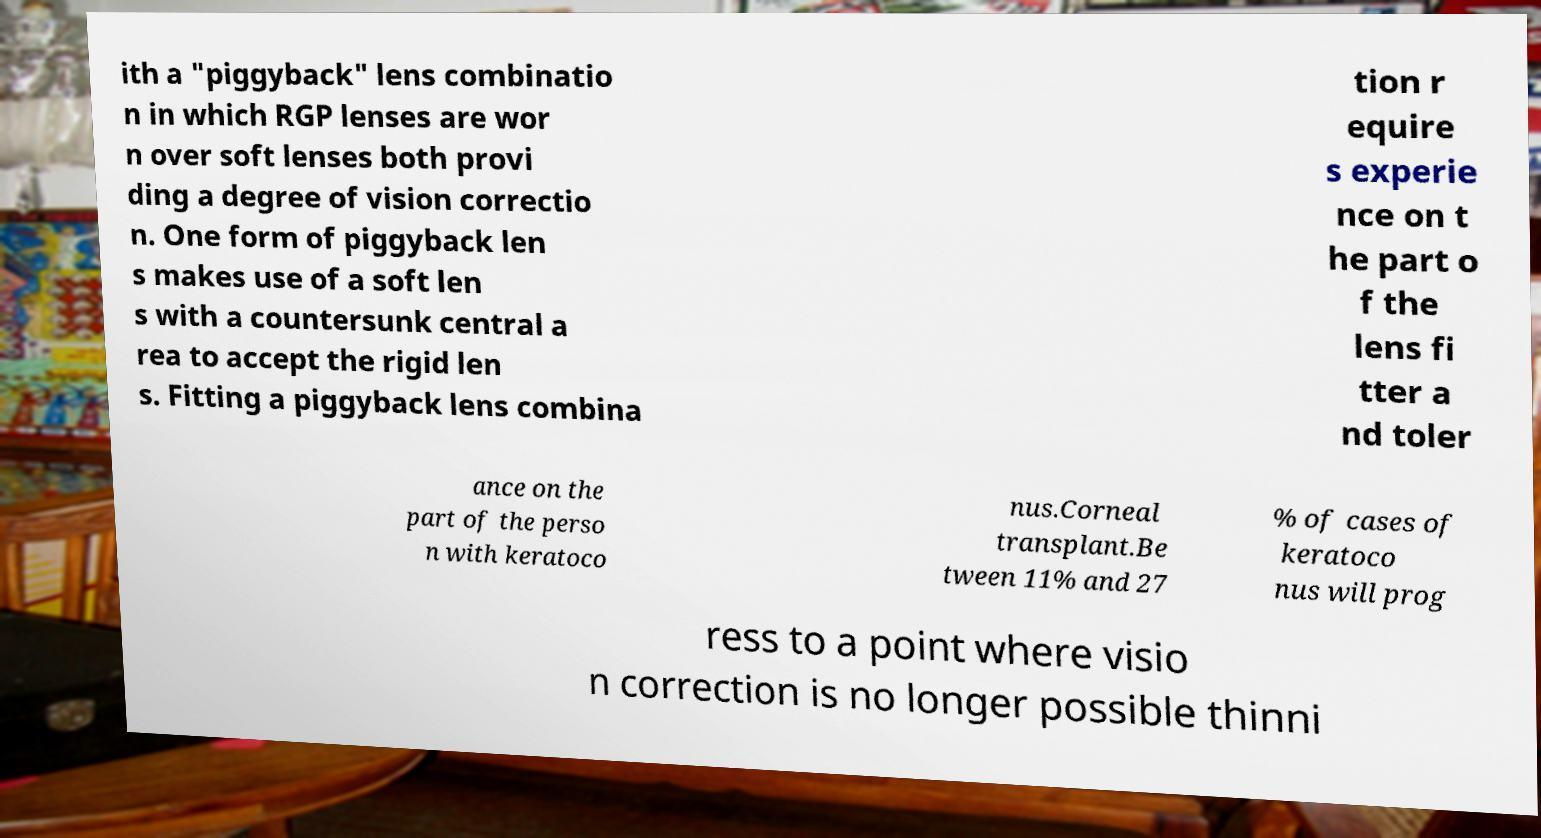Could you extract and type out the text from this image? ith a "piggyback" lens combinatio n in which RGP lenses are wor n over soft lenses both provi ding a degree of vision correctio n. One form of piggyback len s makes use of a soft len s with a countersunk central a rea to accept the rigid len s. Fitting a piggyback lens combina tion r equire s experie nce on t he part o f the lens fi tter a nd toler ance on the part of the perso n with keratoco nus.Corneal transplant.Be tween 11% and 27 % of cases of keratoco nus will prog ress to a point where visio n correction is no longer possible thinni 